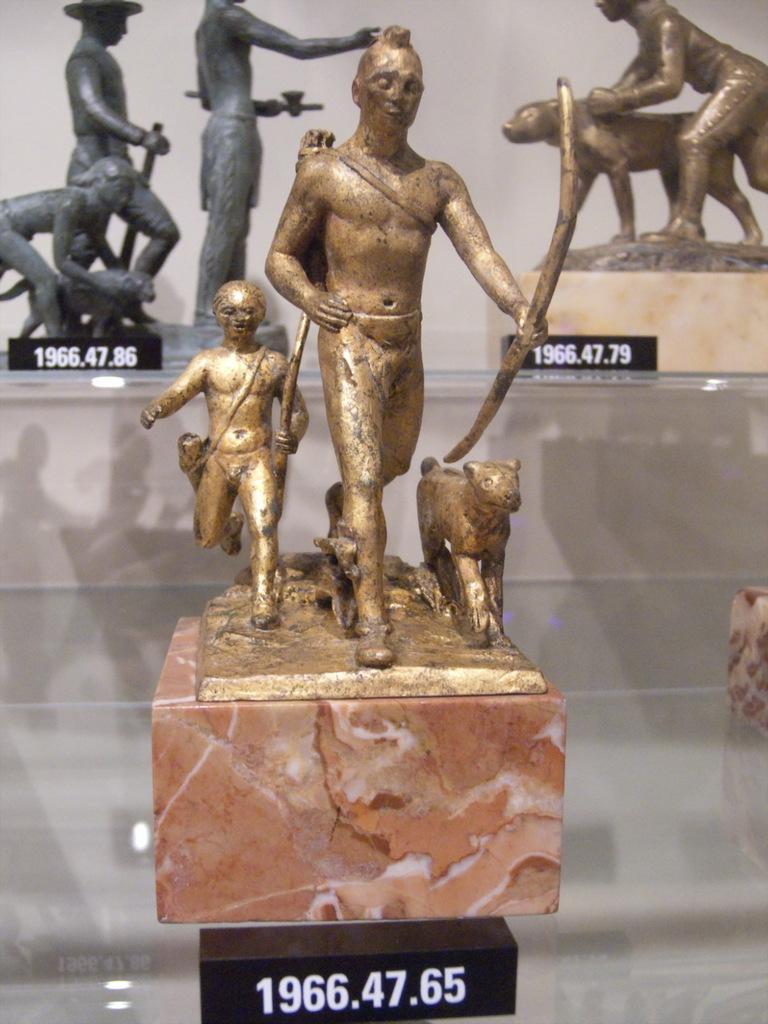Could you give a brief overview of what you see in this image? In this picture we can see couple of idols. 